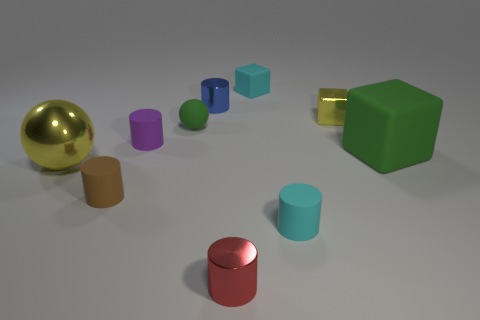Subtract all red cylinders. How many cylinders are left? 4 Subtract all tiny red metallic cylinders. How many cylinders are left? 4 Subtract all yellow cylinders. Subtract all red spheres. How many cylinders are left? 5 Subtract all spheres. How many objects are left? 8 Add 2 large green cubes. How many large green cubes exist? 3 Subtract 0 yellow cylinders. How many objects are left? 10 Subtract all spheres. Subtract all small red matte cylinders. How many objects are left? 8 Add 4 purple cylinders. How many purple cylinders are left? 5 